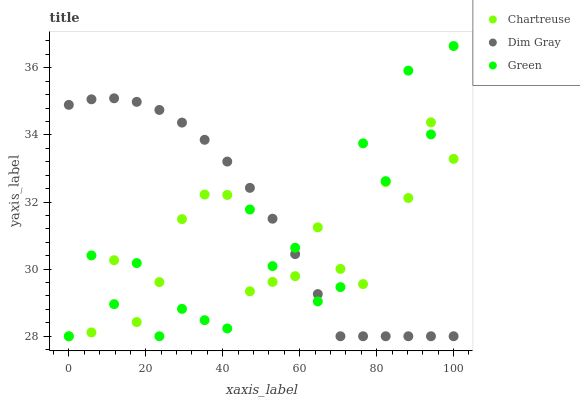Does Chartreuse have the minimum area under the curve?
Answer yes or no. Yes. Does Dim Gray have the maximum area under the curve?
Answer yes or no. Yes. Does Green have the minimum area under the curve?
Answer yes or no. No. Does Green have the maximum area under the curve?
Answer yes or no. No. Is Dim Gray the smoothest?
Answer yes or no. Yes. Is Green the roughest?
Answer yes or no. Yes. Is Green the smoothest?
Answer yes or no. No. Is Dim Gray the roughest?
Answer yes or no. No. Does Chartreuse have the lowest value?
Answer yes or no. Yes. Does Green have the highest value?
Answer yes or no. Yes. Does Dim Gray have the highest value?
Answer yes or no. No. Does Dim Gray intersect Chartreuse?
Answer yes or no. Yes. Is Dim Gray less than Chartreuse?
Answer yes or no. No. Is Dim Gray greater than Chartreuse?
Answer yes or no. No. 